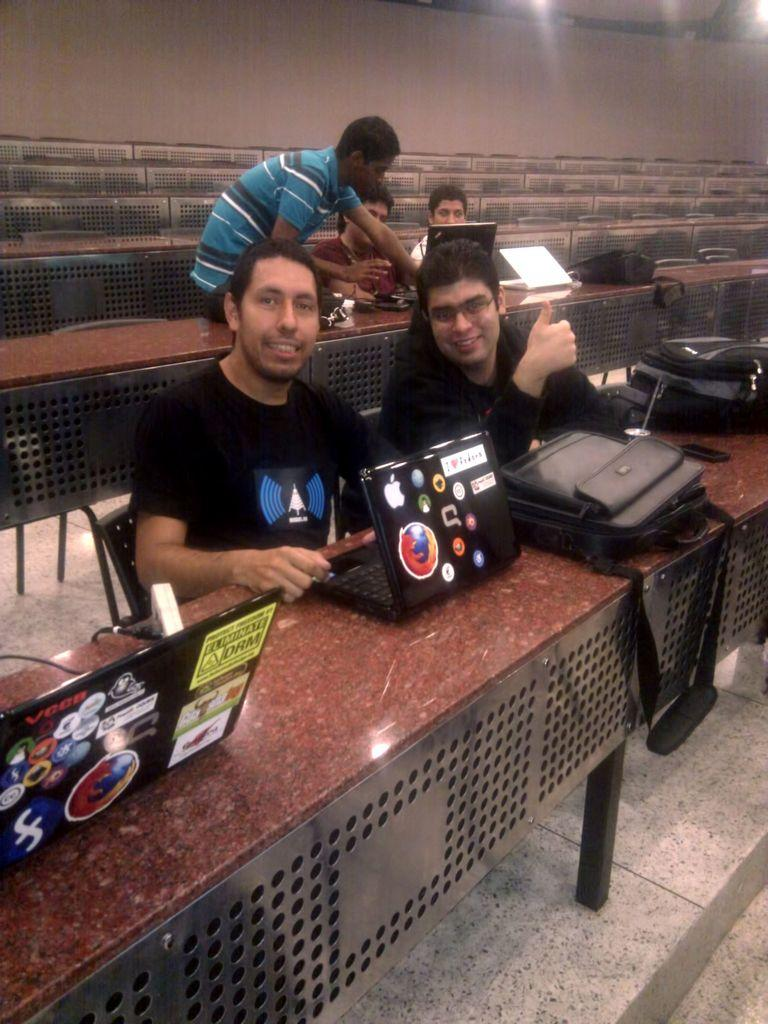What are the people in the image doing? The people in the image are sitting. Is there anyone standing in the image? Yes, there is a person standing in the image. What electronic devices can be seen in the image? There are laptops visible in the image. What items are placed on the tables in the image? There are bags on the tables in the image. What type of credit can be seen being exchanged in the image? There is no credit exchange visible in the image. Can you describe the basin that is present in the image? There is no basin present in the image. 